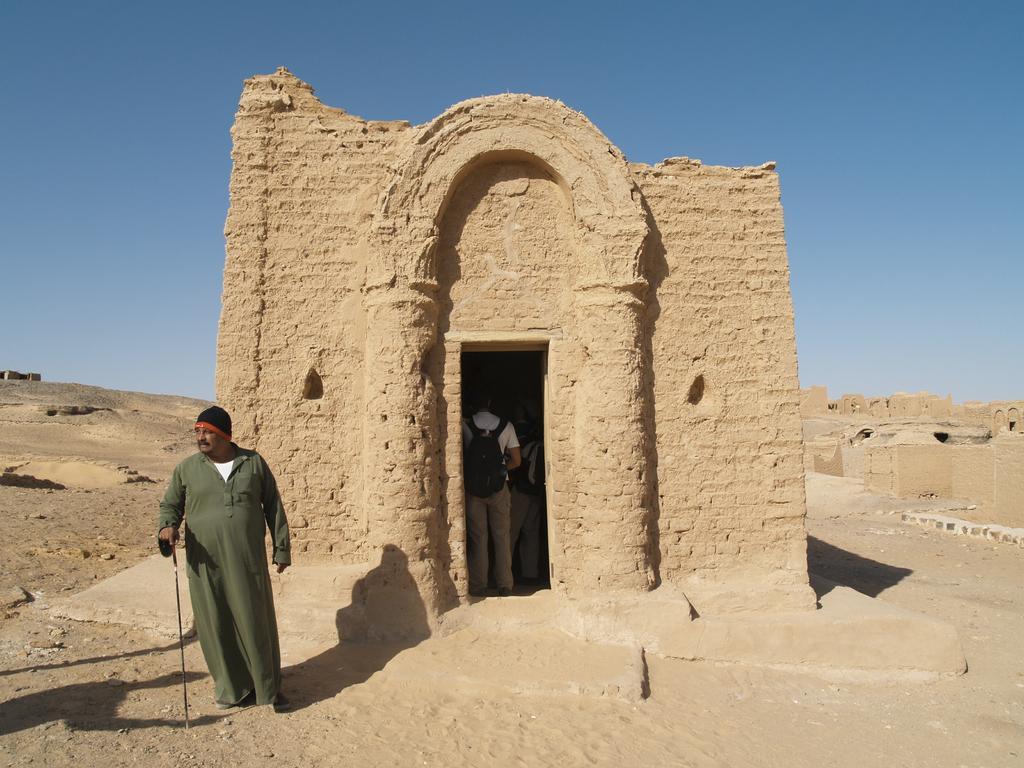How would you summarize this image in a sentence or two? In the center of the image we can see a house and some people are standing and wearing the bags. In the background of the image we can see the soil, houses. At the bottom of the image we can see a man is standing and holding a stick. At the top of the image we can see the sky. 